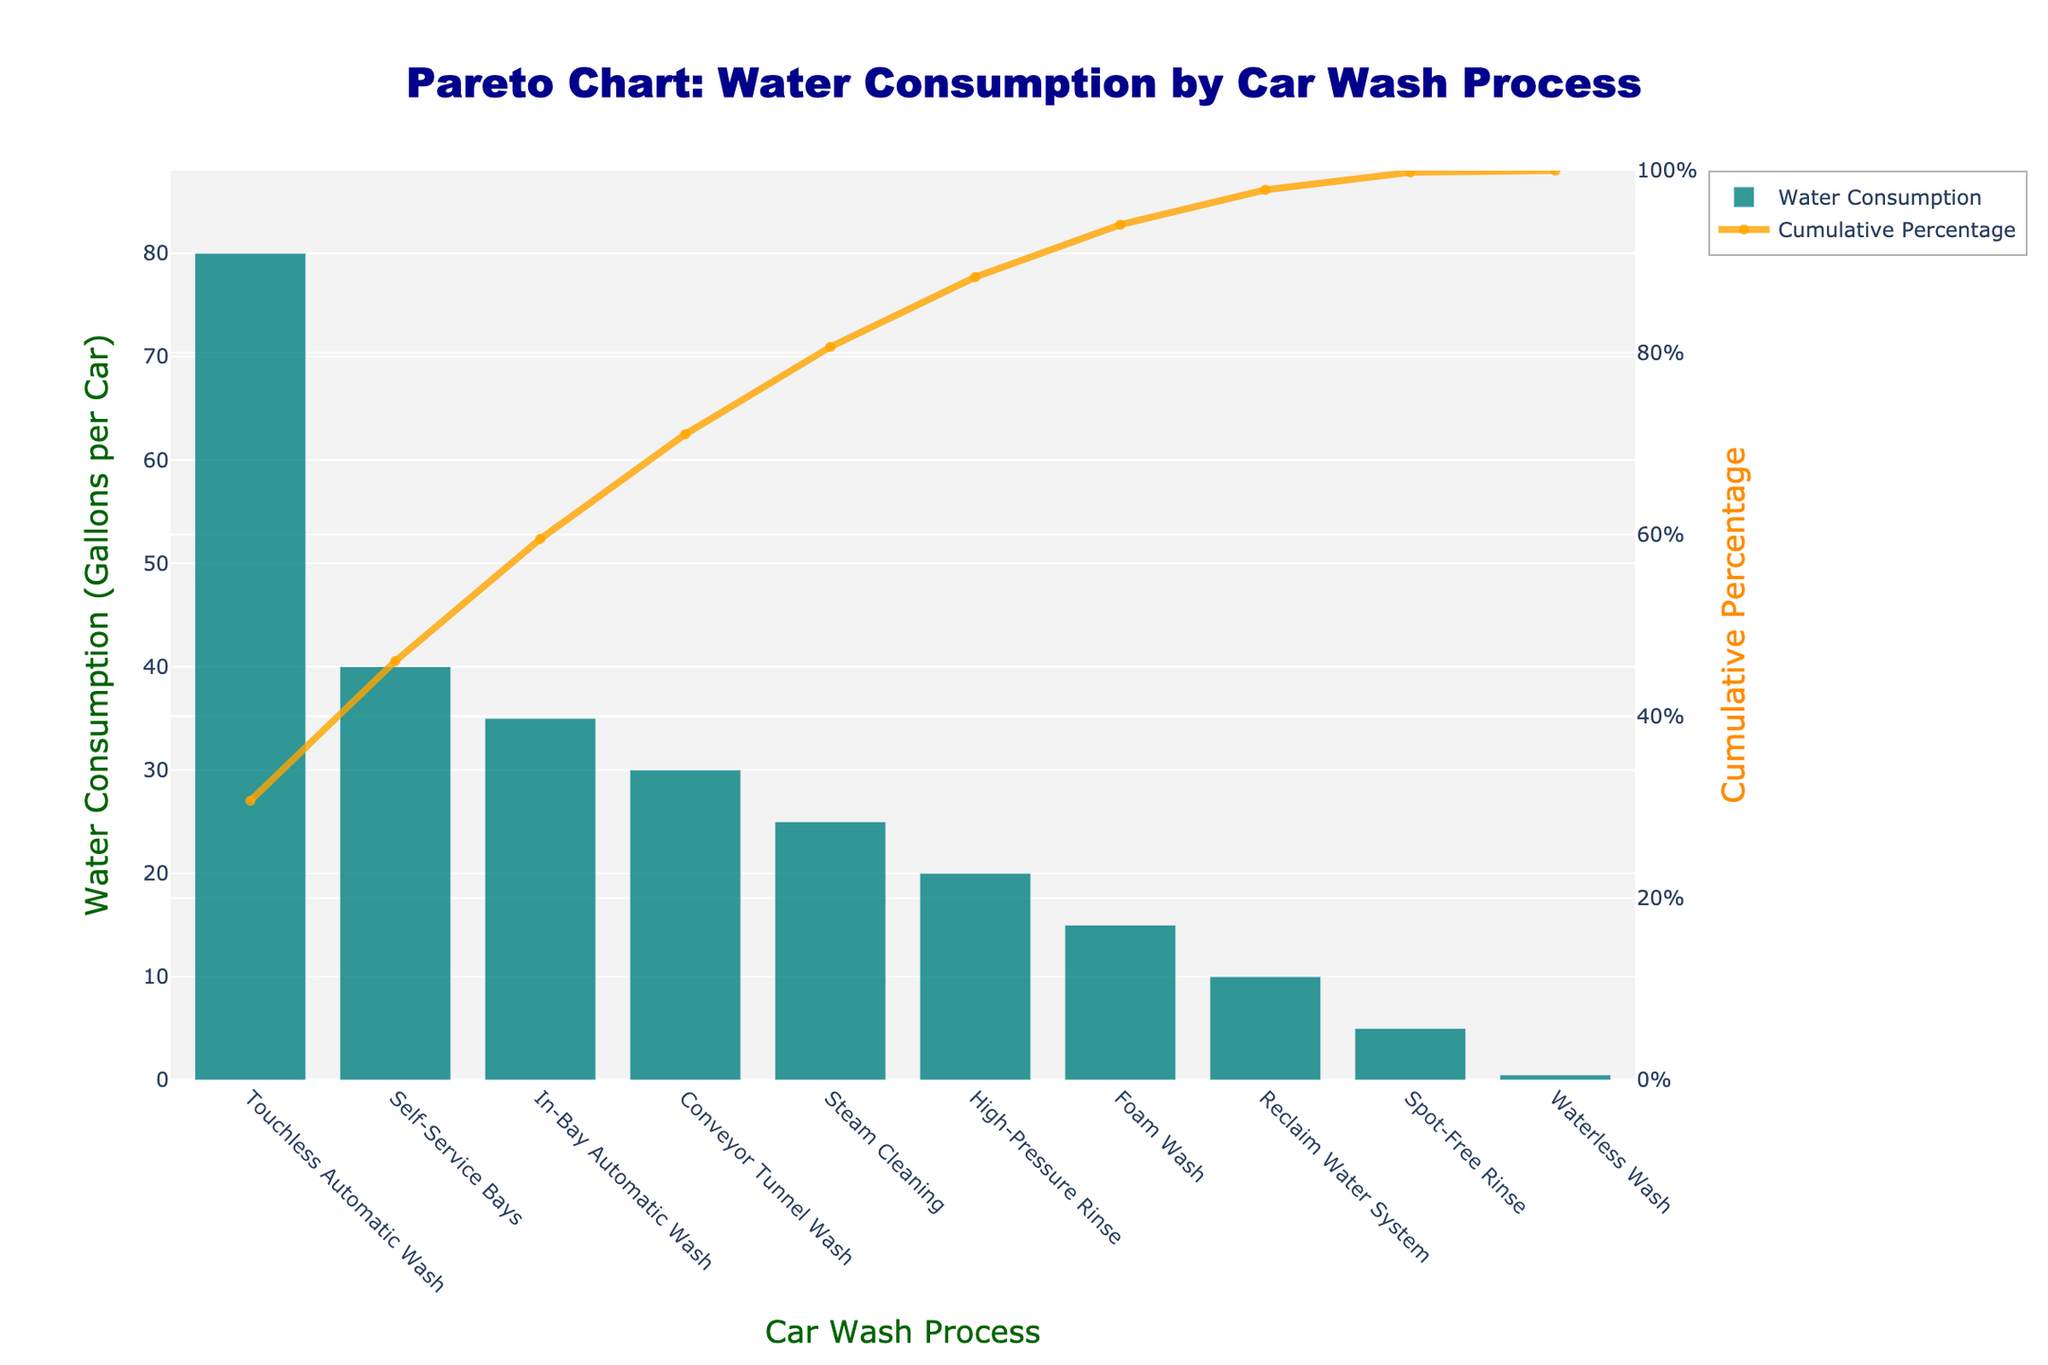What is the title of the figure? The title is located at the top center of the figure and is written in a bold dark blue font.
Answer: Pareto Chart: Water Consumption by Car Wash Process Which car wash process consumes the most water per car? Look for the tallest bar in the figure, which represents the car wash process with the highest water consumption.
Answer: Touchless Automatic Wash What is the cumulative percentage of water consumption after the top three processes? Identify the processes and their cumulative percentage values shown by the orange line on the primary y-axis after the top three processes.
Answer: 69.4% How much water does the Steam Cleaning process use per car? Locate the bar corresponding to the Steam Cleaning process and check its height on the secondary y-axis.
Answer: 25 gallons Which car wash process uses less water per car: High-Pressure Rinse or Foam Wash? Compare the heights of the bars corresponding to High-Pressure Rinse and Foam Wash.
Answer: Foam Wash What is the cumulative percentage after the process consuming the least water? Trace the cumulative percentage line up to the bar representing Waterless Wash, the lowest water-consuming process.
Answer: 100% How many car wash processes consume less than 20 gallons of water per car? Count the bars that are shorter than the 20-gallon mark on the primary y-axis.
Answer: 5 What is the difference in water consumption between the In-Bay Automatic Wash and the High-Pressure Rinse processes? Look at the heights of the bars for both processes and subtract the two values.
Answer: 15 gallons What percentage of total water consumption is due to the top two processes combined? Add the water consumption values of the top two processes, find their combined cumulative percentage on the graph.
Answer: 58.6% How does the water consumption of the Conveyor Tunnel Wash compare to Self-Service Bays in terms of percentage of total consumption? Find the cumulative percentage for both processes and compare them.
Answer: Conveyor Tunnel Wash has a lower cumulative percentage than Self-Service Bays 